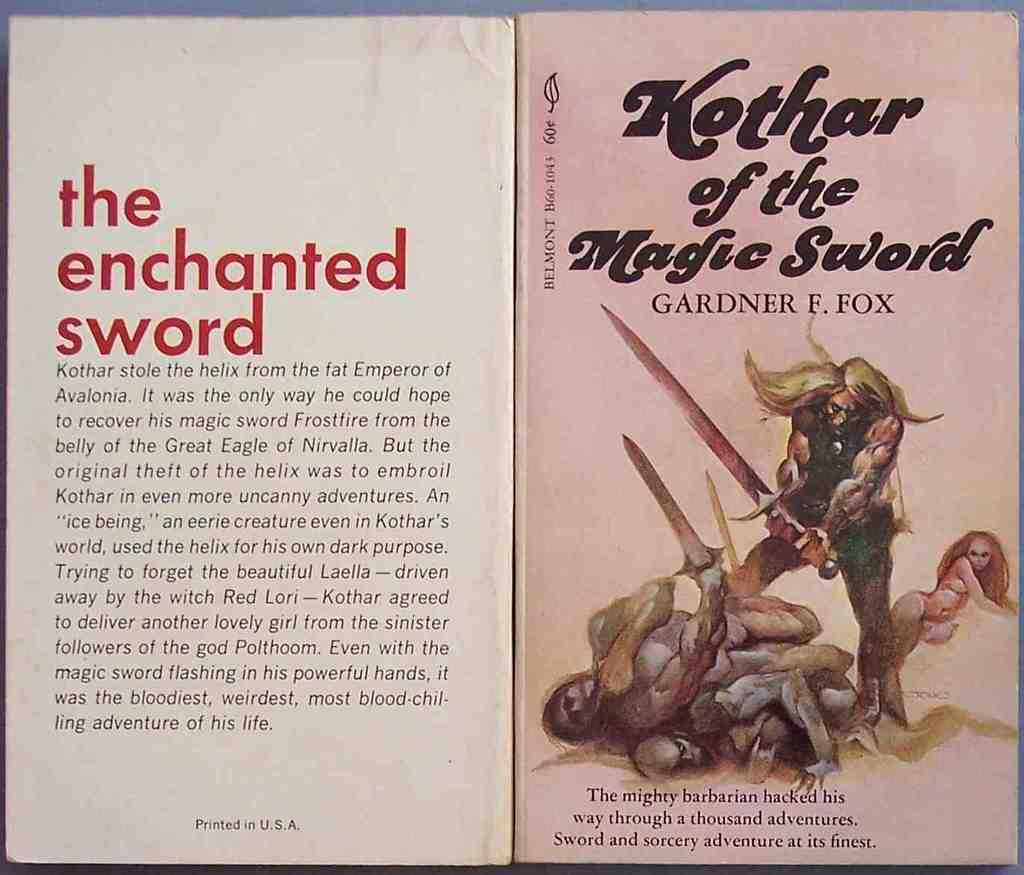Provide a one-sentence caption for the provided image. A book titled Kothar of the Magic Sword by Gardner Fox. 